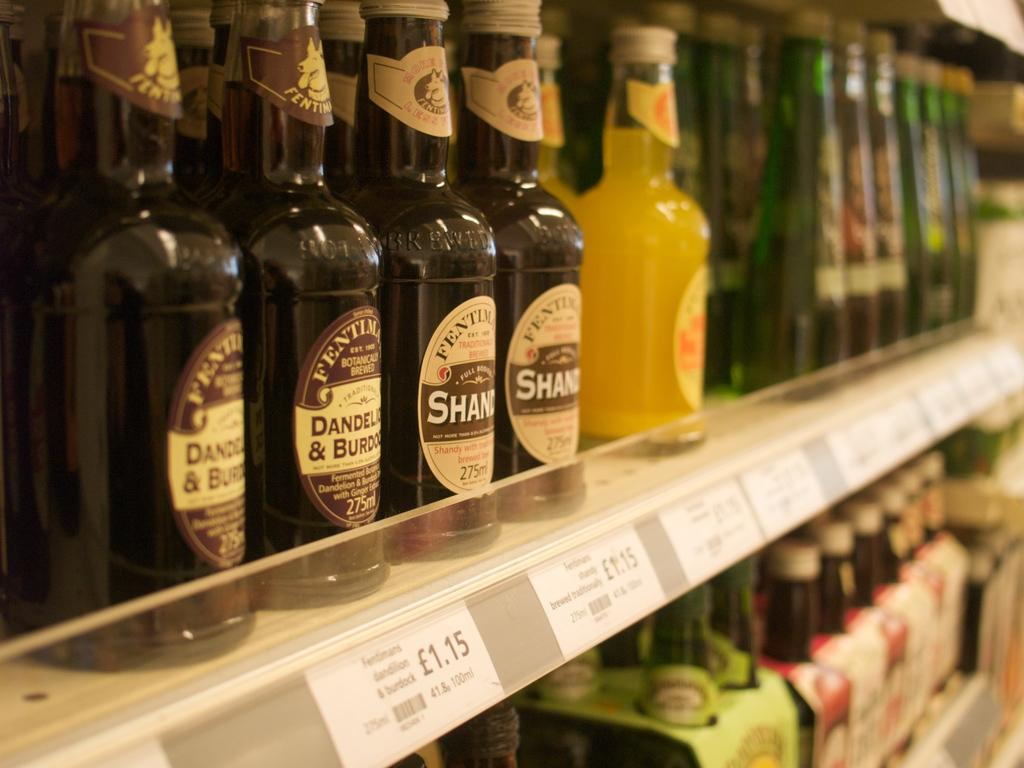Provide a one-sentence caption for the provided image. Alcohol on a shelf in a store which sells for $1.15. 